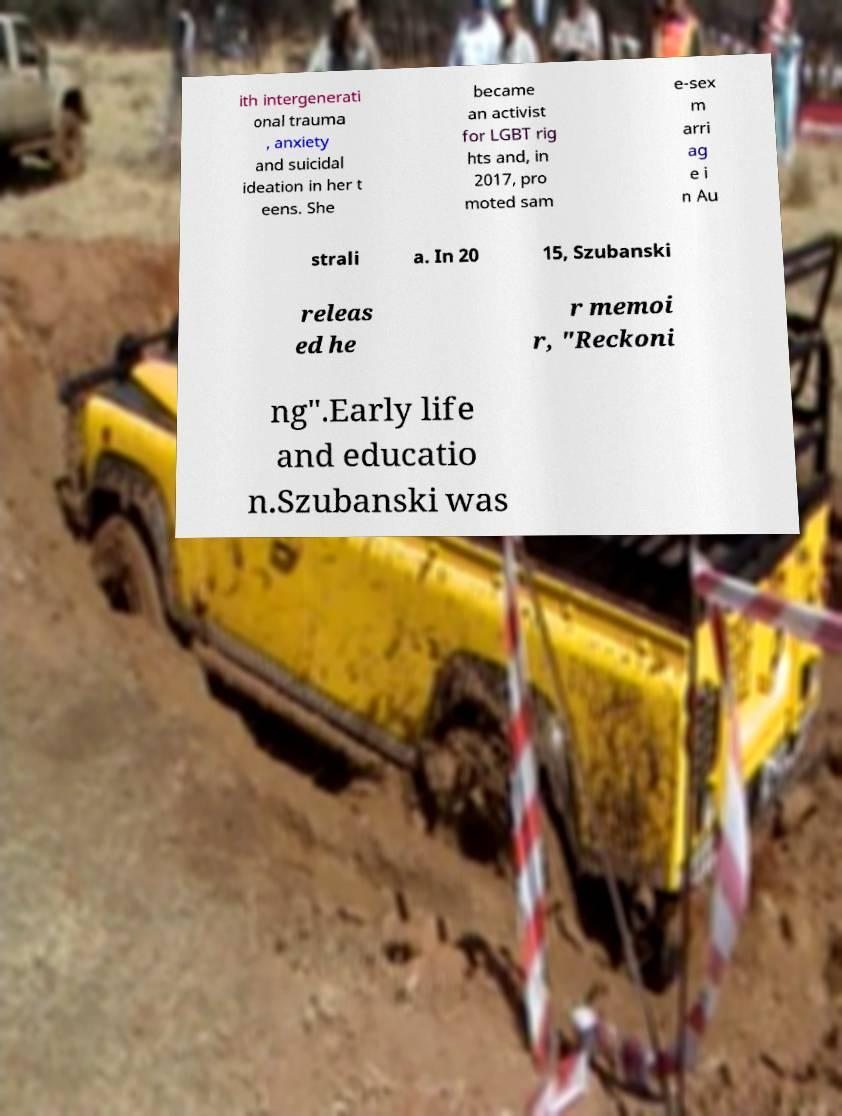For documentation purposes, I need the text within this image transcribed. Could you provide that? ith intergenerati onal trauma , anxiety and suicidal ideation in her t eens. She became an activist for LGBT rig hts and, in 2017, pro moted sam e-sex m arri ag e i n Au strali a. In 20 15, Szubanski releas ed he r memoi r, "Reckoni ng".Early life and educatio n.Szubanski was 